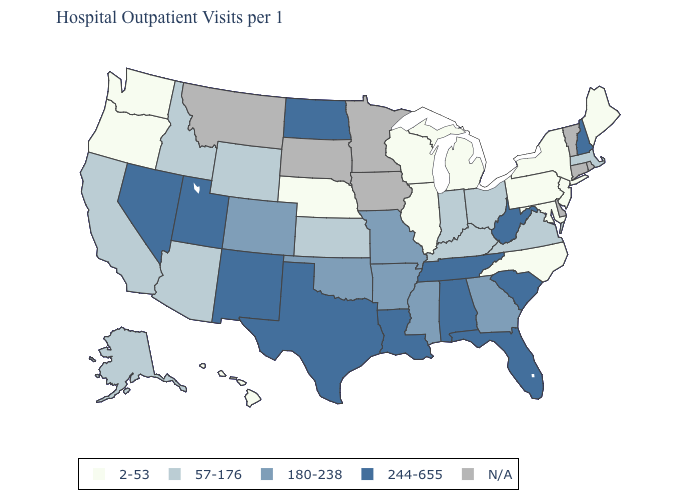What is the highest value in states that border Florida?
Quick response, please. 244-655. What is the value of Washington?
Write a very short answer. 2-53. What is the value of South Dakota?
Be succinct. N/A. What is the highest value in states that border Georgia?
Give a very brief answer. 244-655. Among the states that border Washington , does Idaho have the highest value?
Answer briefly. Yes. What is the value of New Hampshire?
Answer briefly. 244-655. Name the states that have a value in the range 57-176?
Answer briefly. Alaska, Arizona, California, Idaho, Indiana, Kansas, Kentucky, Massachusetts, Ohio, Virginia, Wyoming. What is the value of Georgia?
Give a very brief answer. 180-238. Among the states that border Maryland , which have the highest value?
Keep it brief. West Virginia. Among the states that border Louisiana , which have the highest value?
Concise answer only. Texas. Among the states that border Ohio , which have the highest value?
Quick response, please. West Virginia. What is the lowest value in the South?
Keep it brief. 2-53. Does Florida have the highest value in the South?
Quick response, please. Yes. Among the states that border Florida , which have the lowest value?
Quick response, please. Georgia. 